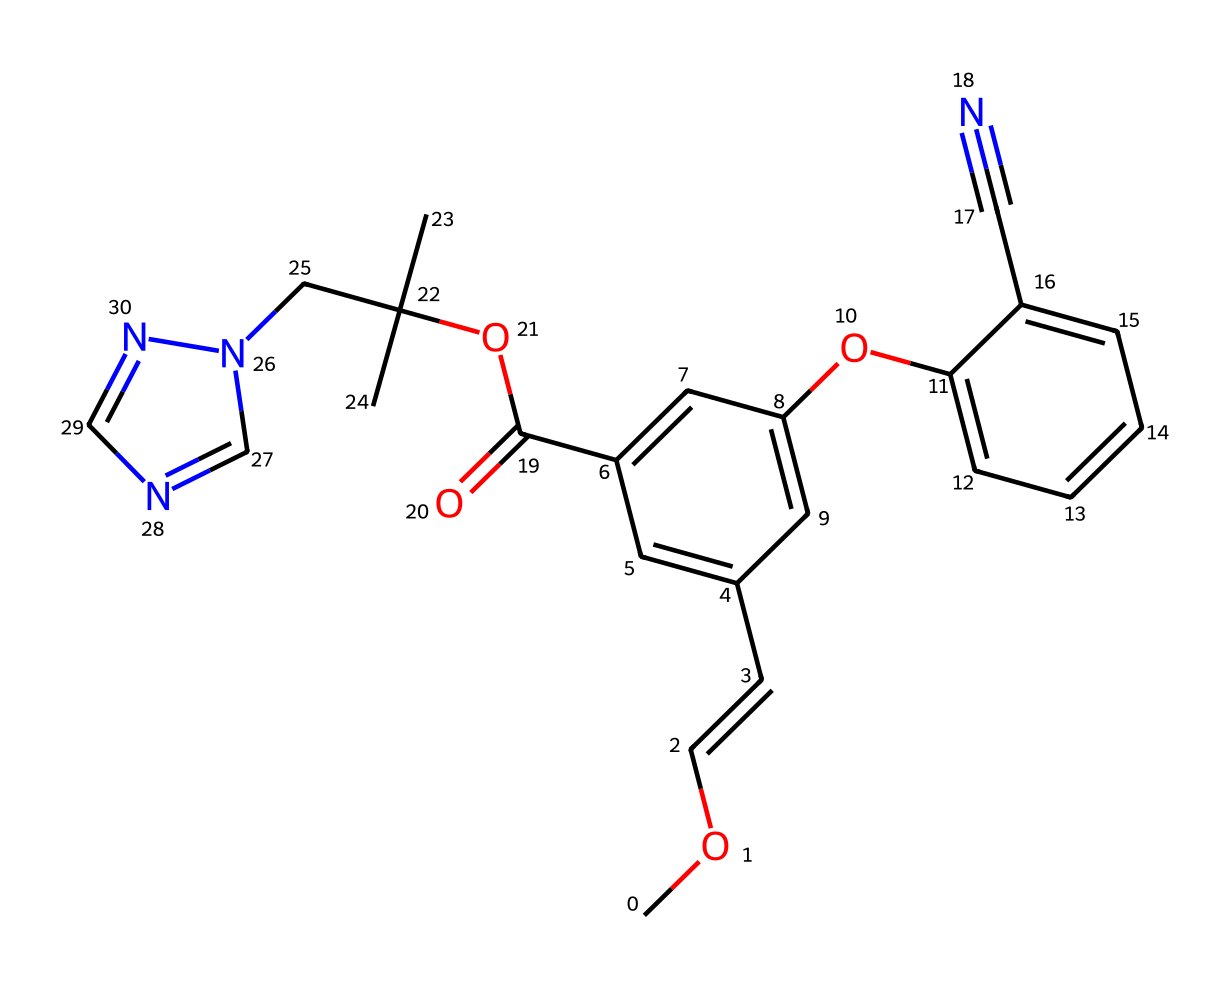What is the main functional group present in azoxystrobin? The main functional group in azoxystrobin is an ester, indicated by the presence of double-bonded oxygen (C=O) adjacent to an alkyl group (OC).
Answer: ester How many carbon atoms are present in azoxystrobin? By analyzing the SMILES representation, we can count the number of carbon atoms present in the structure, which totals to 20.
Answer: 20 What type of ring system is observed in azoxystrobin? The presence of a six-membered aromatic ring (indicated by the alternating double bonds and connectivity) characterizes azoxystrobin's structure.
Answer: aromatic What is the molecular weight of azoxystrobin? The molecular weight can be calculated by summing up the atomic weights of each atom in the compound as specified in the SMILES notation, yielding a total of approximately 357.43 g/mol.
Answer: 357.43 g/mol Does azoxystrobin contain any nitrogen atoms? By inspecting the SMILES structure, nitrogen atoms are clearly identified in the structure, showing that there are two nitrogen atoms present in azoxystrobin.
Answer: 2 Which part of the structure contributes to the fungicidal activity of azoxystrobin? The large conjugated system including the aromatic rings and the methylated nitrogen may enhance the biological activity contributing to the fungicidal properties of azoxystrobin.
Answer: conjugated system What is the significance of the cyano group in azoxystrobin? The cyano group, represented as C#N in the structure, is essential as it can contribute to the electronic properties, enhancing reactivity and stability in the fungicidal action of azoxystrobin.
Answer: electronic properties 